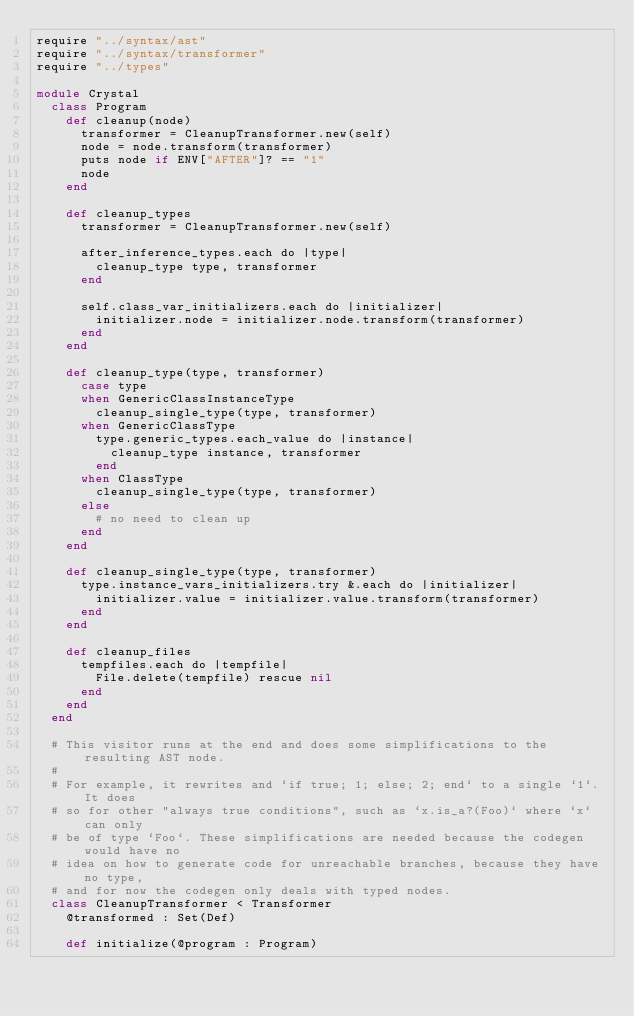<code> <loc_0><loc_0><loc_500><loc_500><_Crystal_>require "../syntax/ast"
require "../syntax/transformer"
require "../types"

module Crystal
  class Program
    def cleanup(node)
      transformer = CleanupTransformer.new(self)
      node = node.transform(transformer)
      puts node if ENV["AFTER"]? == "1"
      node
    end

    def cleanup_types
      transformer = CleanupTransformer.new(self)

      after_inference_types.each do |type|
        cleanup_type type, transformer
      end

      self.class_var_initializers.each do |initializer|
        initializer.node = initializer.node.transform(transformer)
      end
    end

    def cleanup_type(type, transformer)
      case type
      when GenericClassInstanceType
        cleanup_single_type(type, transformer)
      when GenericClassType
        type.generic_types.each_value do |instance|
          cleanup_type instance, transformer
        end
      when ClassType
        cleanup_single_type(type, transformer)
      else
        # no need to clean up
      end
    end

    def cleanup_single_type(type, transformer)
      type.instance_vars_initializers.try &.each do |initializer|
        initializer.value = initializer.value.transform(transformer)
      end
    end

    def cleanup_files
      tempfiles.each do |tempfile|
        File.delete(tempfile) rescue nil
      end
    end
  end

  # This visitor runs at the end and does some simplifications to the resulting AST node.
  #
  # For example, it rewrites and `if true; 1; else; 2; end` to a single `1`. It does
  # so for other "always true conditions", such as `x.is_a?(Foo)` where `x` can only
  # be of type `Foo`. These simplifications are needed because the codegen would have no
  # idea on how to generate code for unreachable branches, because they have no type,
  # and for now the codegen only deals with typed nodes.
  class CleanupTransformer < Transformer
    @transformed : Set(Def)

    def initialize(@program : Program)</code> 